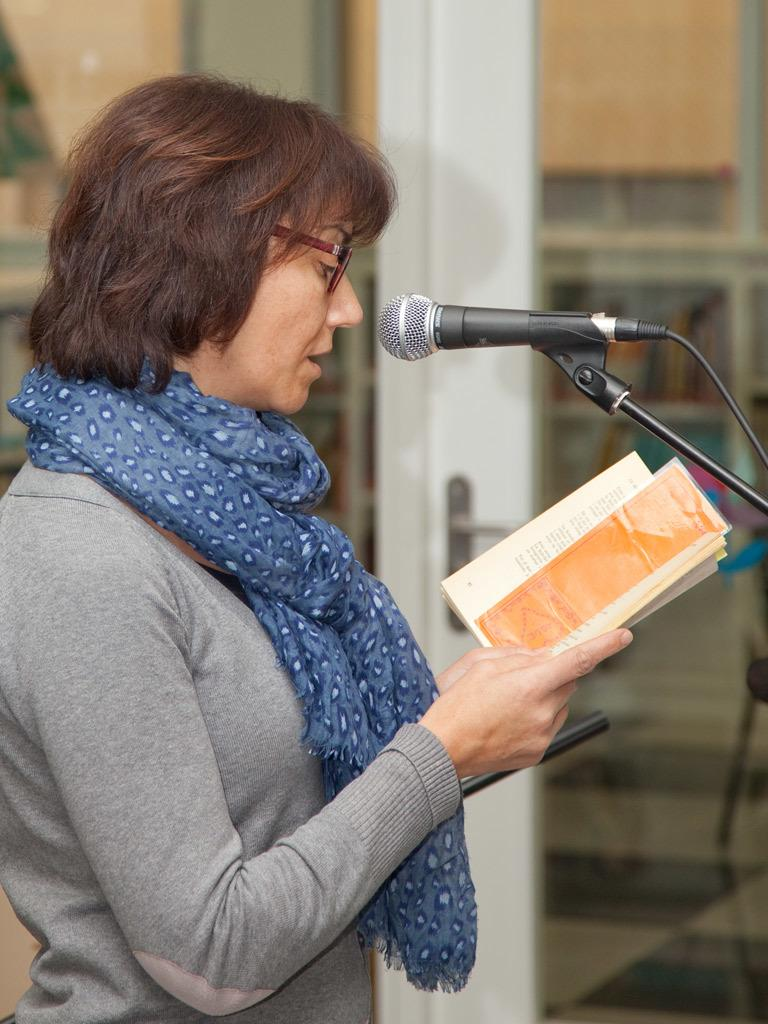What is the main subject of the image? There is a woman in the image. What is the woman doing in the image? The woman is standing in the image. What is the woman holding in her hand? The woman is holding a book in her hand. What object is near the woman in the image? The woman is standing by a microphone. What can be seen in the background of the image? There is a glass and other objects visible in the background of the image. How many brothers does the woman have, and what are they doing in the image? There is no information about the woman's brothers in the image, nor are they present. 